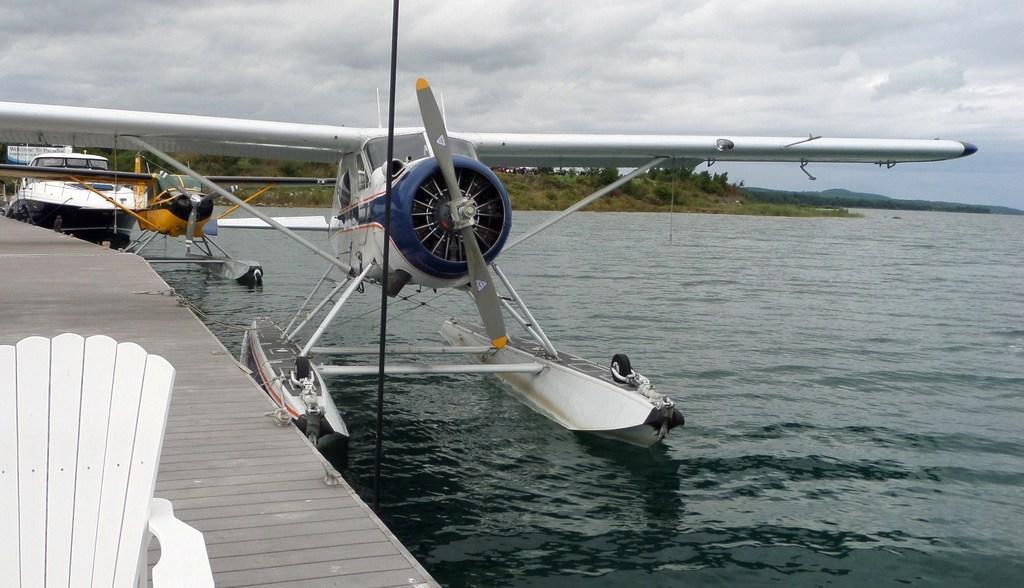Can you describe this image briefly? In this picture I can observe two flying boats. They are in white and yellow colors. These flying boats are floating on the water. On the left side there is a platform. I can observe a boat on the left side. In the background there are trees and a sky with some clouds. 